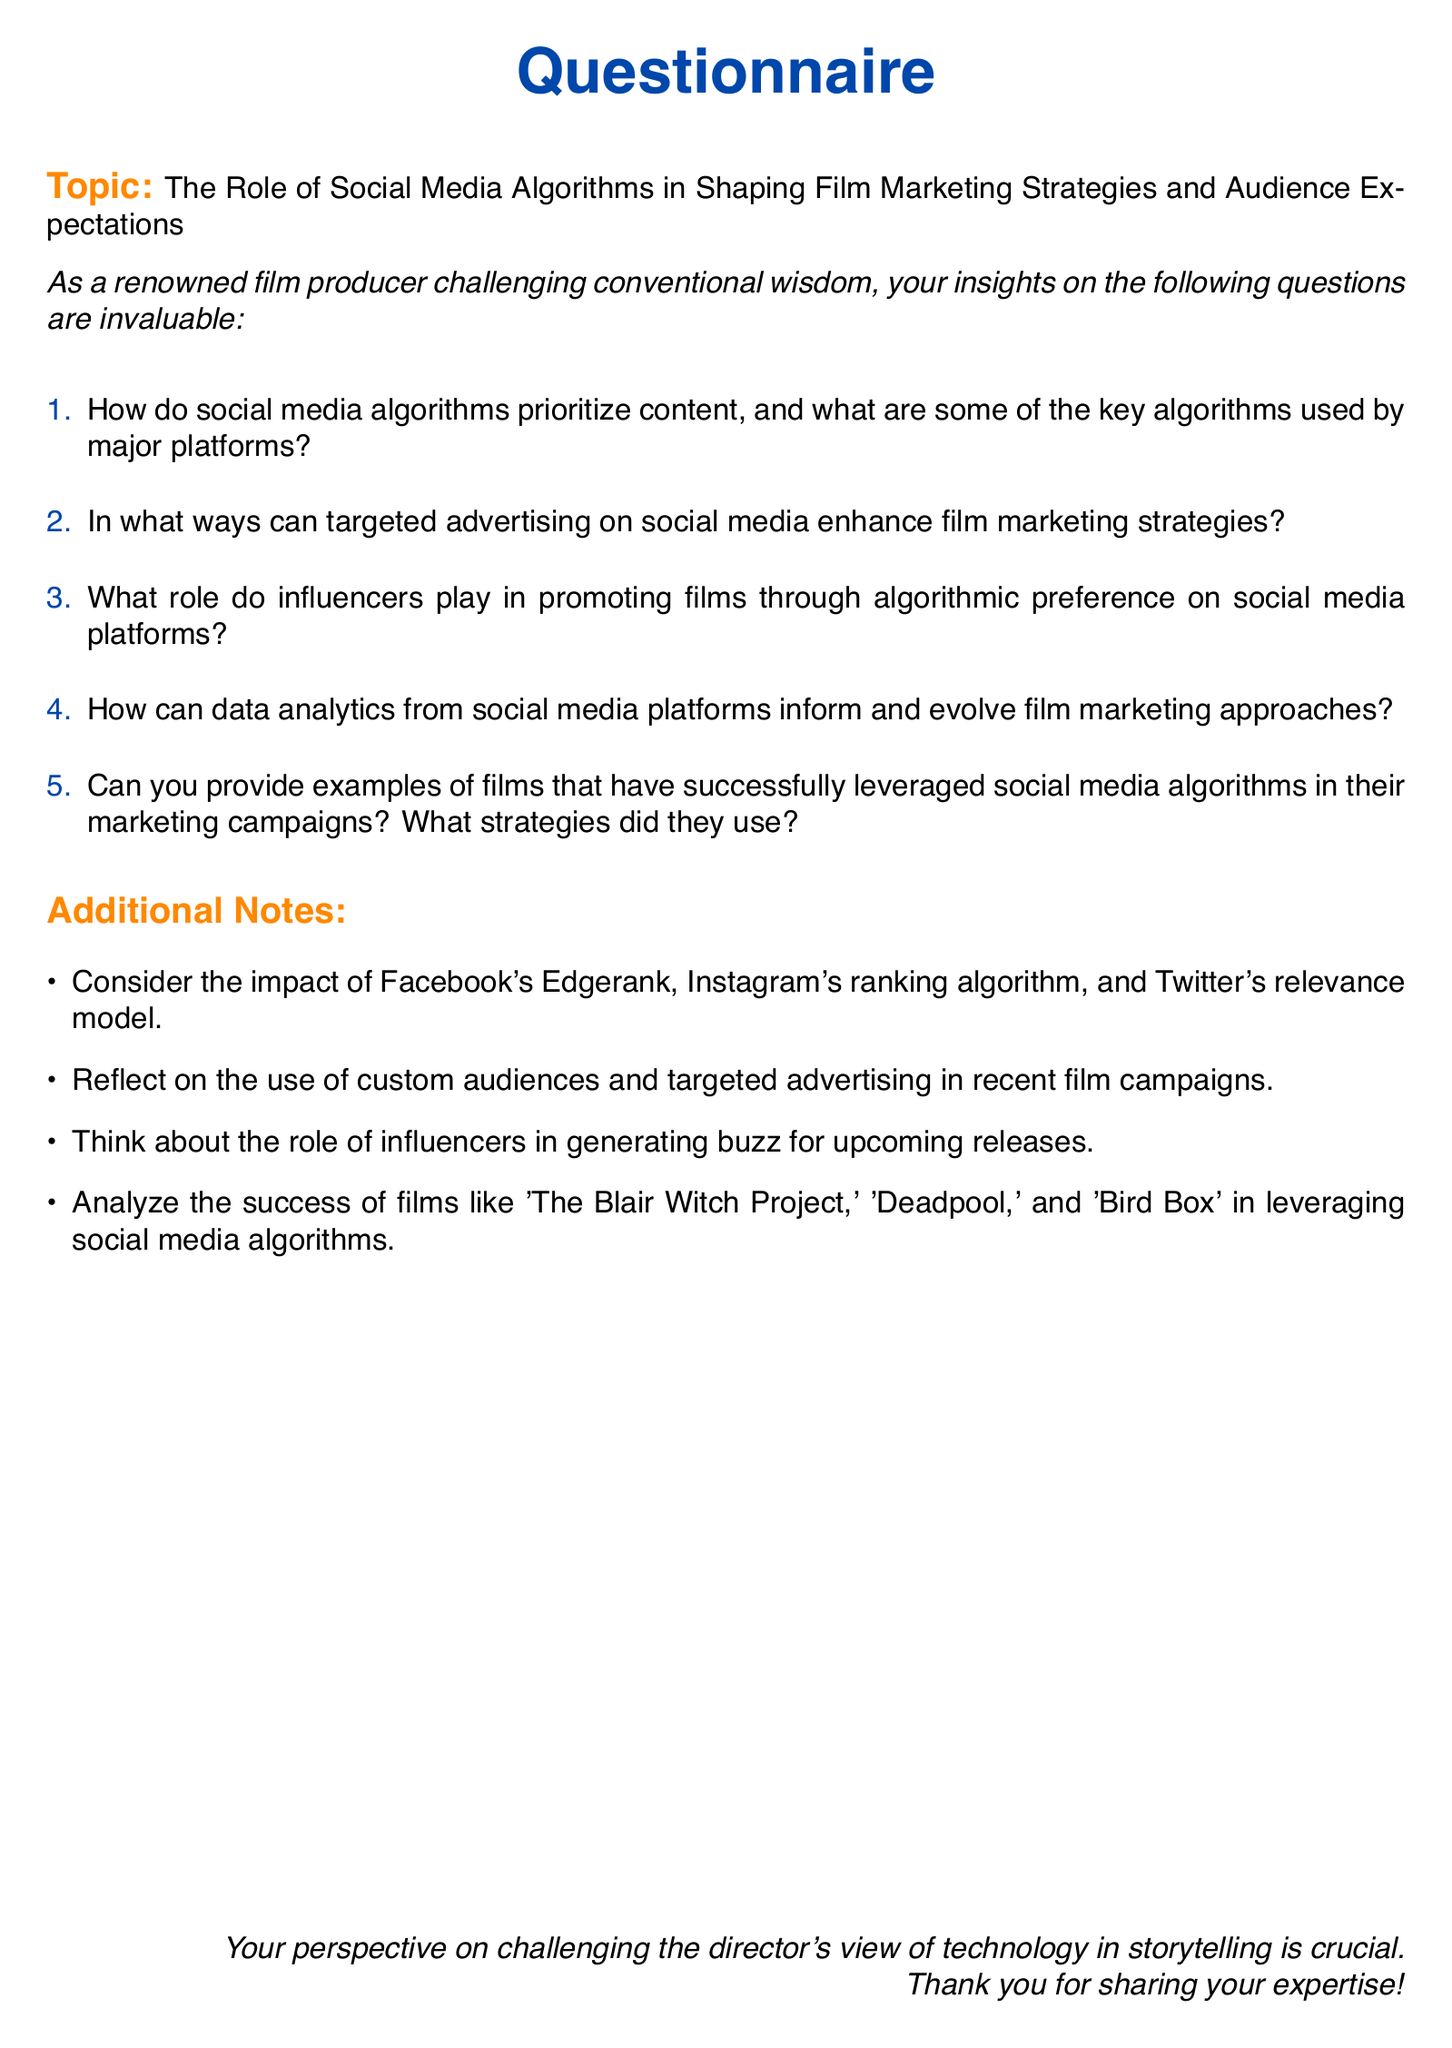What is the main topic of the questionnaire? The main topic is indicated at the beginning of the document.
Answer: The Role of Social Media Algorithms in Shaping Film Marketing Strategies and Audience Expectations How many questions are listed in the questionnaire? The number of questions can be counted from the enumerated list in the document.
Answer: Five What color is used for the header of the questionnaire? The color specified for the header can be found in the document settings.
Answer: Film blue Which film is mentioned as a successful example of leveraging social media algorithms? The document provides specific examples of films that have used social media algorithms.
Answer: The Blair Witch Project What marketing strategy is suggested for films in the questionnaire? The document discusses aspects of marketing based on social media analytics.
Answer: Targeted advertising What is mentioned as a consideration under additional notes? The additional notes section provides specific aspects to reflect on regarding social media algorithms.
Answer: The impact of Facebook's Edgerank What role do influencers play according to the questions? The document suggests a specific role for influencers in promoting films through social media.
Answer: Promoting films through algorithmic preference Which films are referenced in relation to social media algorithms? The document provides specific cases for analysis in the context of social media marketing.
Answer: Deadpool and Bird Box 